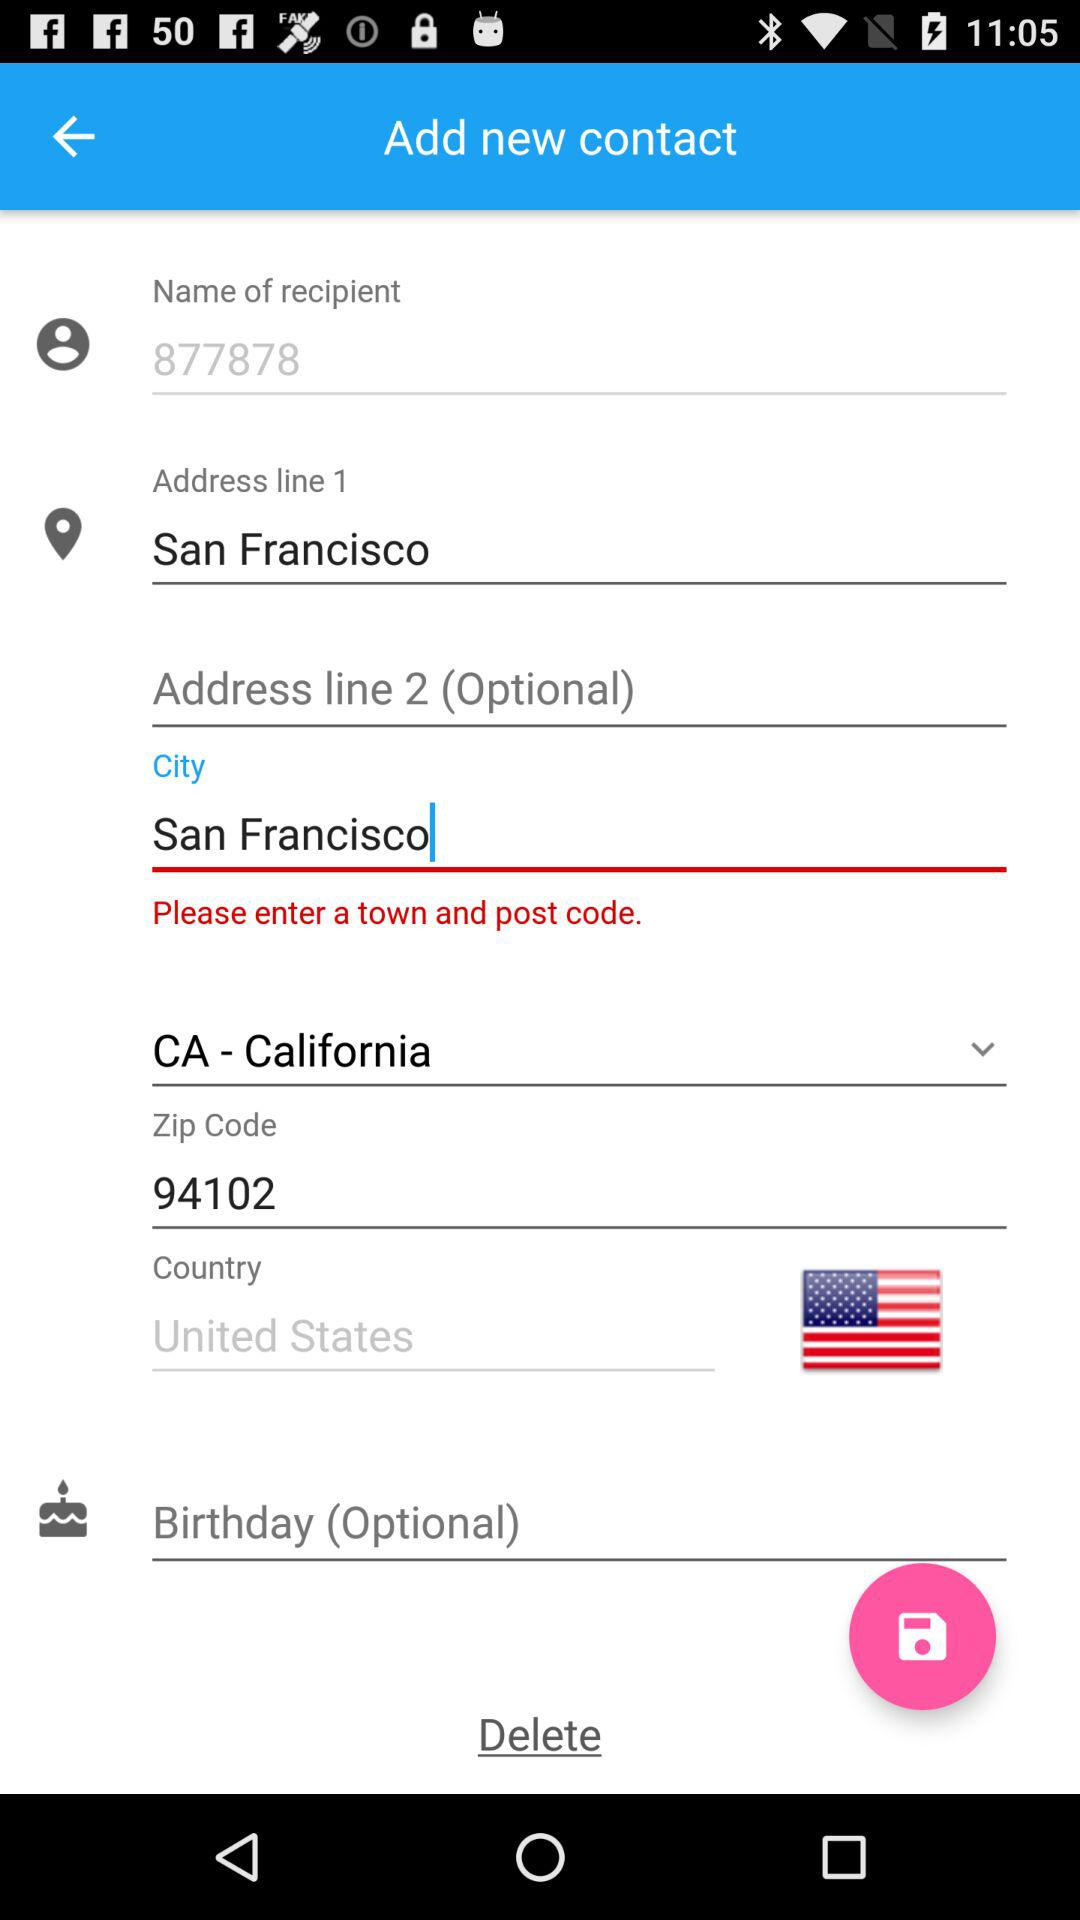What is written in "Address line 1"? In "Address line 1", San Francisco is written. 